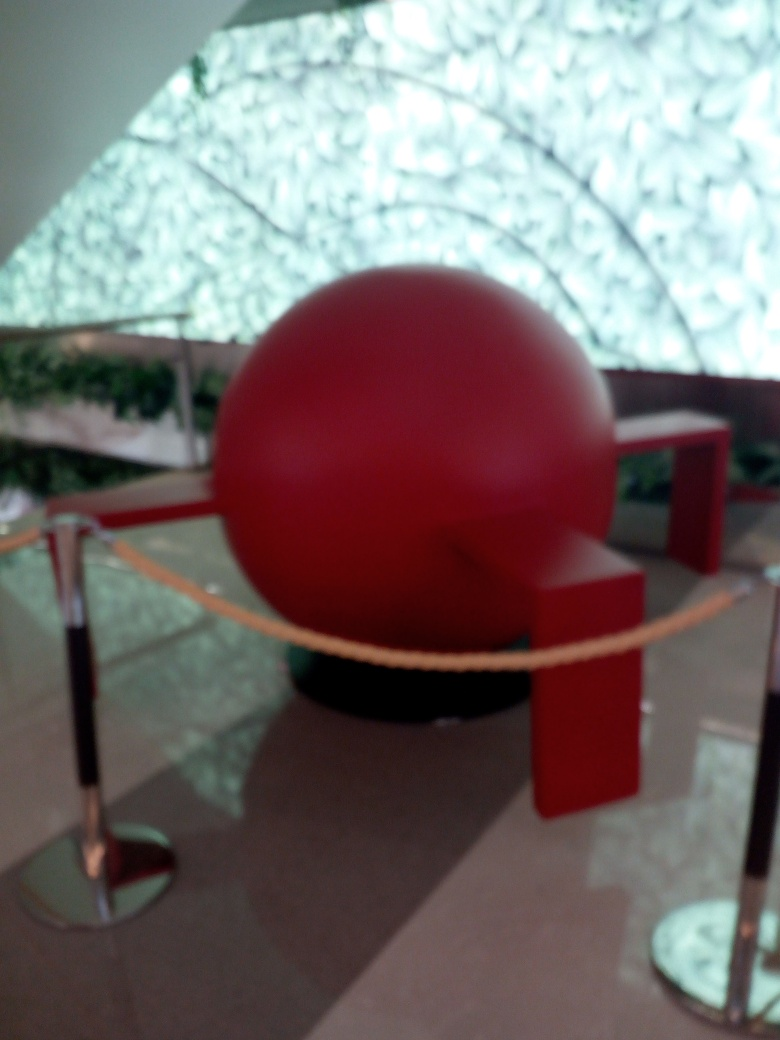Is the image sharp? The image is not sharp; it's quite blurry, affecting the clarity of the details. For instance, the shapes and textures within the image, such as the red spherical object and the background elements, lack definition. 